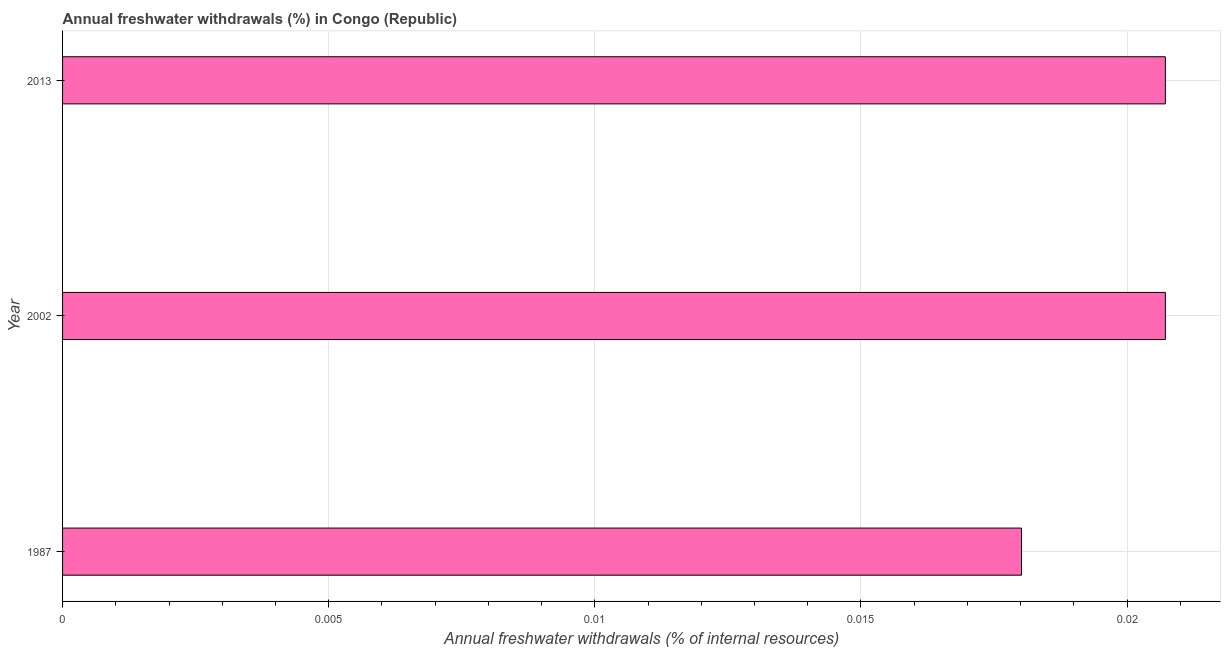Does the graph contain grids?
Offer a terse response. Yes. What is the title of the graph?
Offer a very short reply. Annual freshwater withdrawals (%) in Congo (Republic). What is the label or title of the X-axis?
Provide a short and direct response. Annual freshwater withdrawals (% of internal resources). What is the label or title of the Y-axis?
Your answer should be compact. Year. What is the annual freshwater withdrawals in 2013?
Provide a short and direct response. 0.02. Across all years, what is the maximum annual freshwater withdrawals?
Your response must be concise. 0.02. Across all years, what is the minimum annual freshwater withdrawals?
Your answer should be very brief. 0.02. In which year was the annual freshwater withdrawals maximum?
Offer a very short reply. 2002. What is the sum of the annual freshwater withdrawals?
Your answer should be very brief. 0.06. What is the difference between the annual freshwater withdrawals in 2002 and 2013?
Provide a succinct answer. 0. What is the average annual freshwater withdrawals per year?
Keep it short and to the point. 0.02. What is the median annual freshwater withdrawals?
Your answer should be compact. 0.02. In how many years, is the annual freshwater withdrawals greater than 0.016 %?
Ensure brevity in your answer.  3. What is the ratio of the annual freshwater withdrawals in 1987 to that in 2013?
Offer a very short reply. 0.87. Is the difference between the annual freshwater withdrawals in 1987 and 2002 greater than the difference between any two years?
Ensure brevity in your answer.  Yes. What is the difference between the highest and the second highest annual freshwater withdrawals?
Your response must be concise. 0. Is the sum of the annual freshwater withdrawals in 2002 and 2013 greater than the maximum annual freshwater withdrawals across all years?
Offer a very short reply. Yes. In how many years, is the annual freshwater withdrawals greater than the average annual freshwater withdrawals taken over all years?
Your response must be concise. 2. How many bars are there?
Keep it short and to the point. 3. How many years are there in the graph?
Give a very brief answer. 3. What is the difference between two consecutive major ticks on the X-axis?
Offer a terse response. 0.01. What is the Annual freshwater withdrawals (% of internal resources) in 1987?
Ensure brevity in your answer.  0.02. What is the Annual freshwater withdrawals (% of internal resources) in 2002?
Your response must be concise. 0.02. What is the Annual freshwater withdrawals (% of internal resources) in 2013?
Your answer should be very brief. 0.02. What is the difference between the Annual freshwater withdrawals (% of internal resources) in 1987 and 2002?
Provide a short and direct response. -0. What is the difference between the Annual freshwater withdrawals (% of internal resources) in 1987 and 2013?
Keep it short and to the point. -0. What is the difference between the Annual freshwater withdrawals (% of internal resources) in 2002 and 2013?
Provide a short and direct response. 0. What is the ratio of the Annual freshwater withdrawals (% of internal resources) in 1987 to that in 2002?
Your answer should be very brief. 0.87. What is the ratio of the Annual freshwater withdrawals (% of internal resources) in 1987 to that in 2013?
Provide a succinct answer. 0.87. What is the ratio of the Annual freshwater withdrawals (% of internal resources) in 2002 to that in 2013?
Offer a very short reply. 1. 